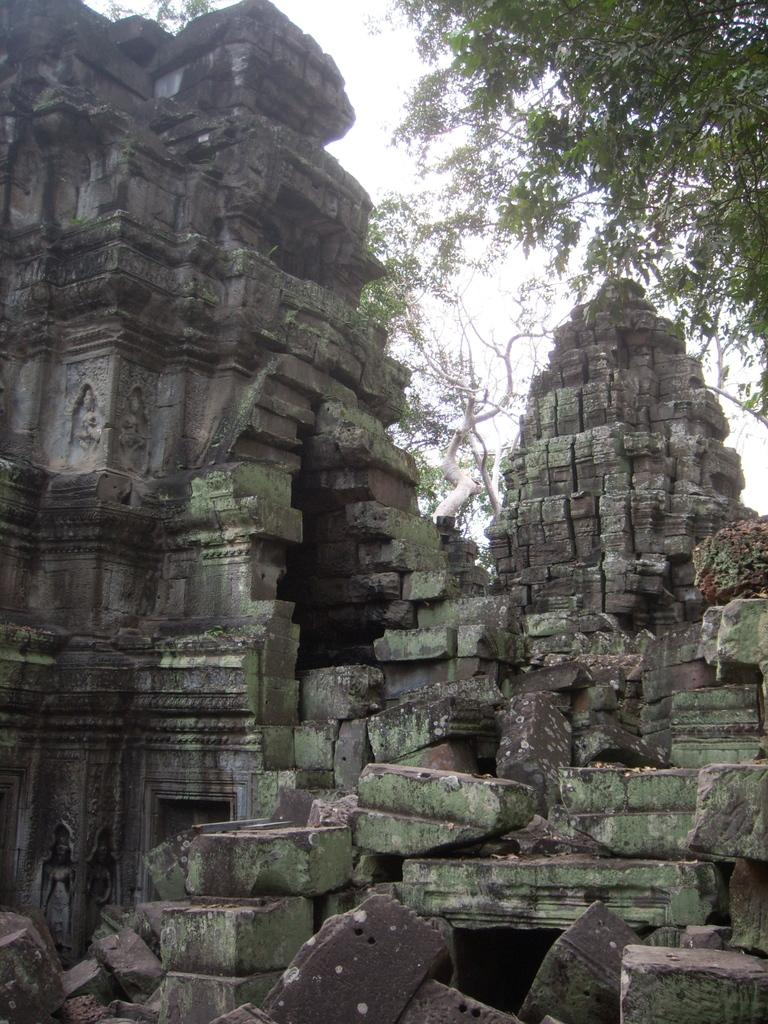What is the main subject in the center of the image? There is an old temple in the center of the image. What can be seen in the background of the image? There are trees in the background of the image. What shape is the grape in the image? There is no grape present in the image. How does the addition of a new column affect the temple's structure in the image? The image does not show any changes to the temple's structure, so it is not possible to determine the effect of adding a new column. 